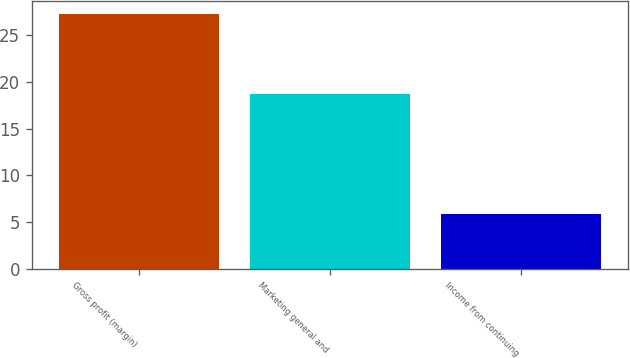Convert chart. <chart><loc_0><loc_0><loc_500><loc_500><bar_chart><fcel>Gross profit (margin)<fcel>Marketing general and<fcel>Income from continuing<nl><fcel>27.3<fcel>18.7<fcel>5.9<nl></chart> 